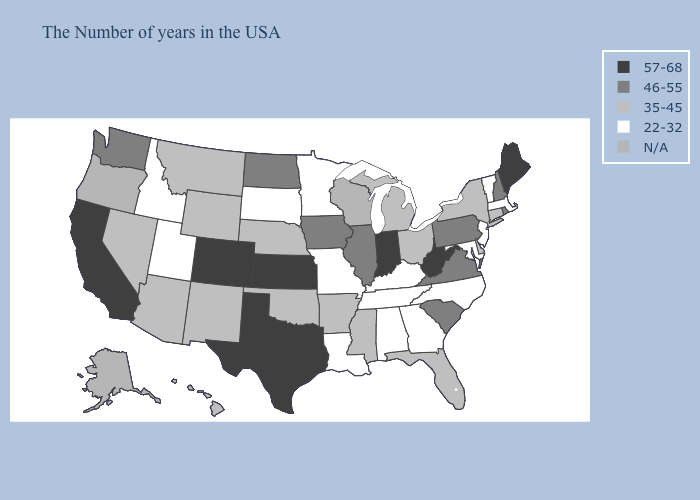How many symbols are there in the legend?
Concise answer only. 5. Does Oklahoma have the lowest value in the USA?
Keep it brief. No. Does the first symbol in the legend represent the smallest category?
Be succinct. No. Does Indiana have the highest value in the MidWest?
Short answer required. Yes. Is the legend a continuous bar?
Be succinct. No. Name the states that have a value in the range 57-68?
Give a very brief answer. Maine, West Virginia, Indiana, Kansas, Texas, Colorado, California. Which states have the highest value in the USA?
Write a very short answer. Maine, West Virginia, Indiana, Kansas, Texas, Colorado, California. Is the legend a continuous bar?
Short answer required. No. What is the value of Kentucky?
Keep it brief. 22-32. Among the states that border Iowa , which have the highest value?
Answer briefly. Illinois. Which states hav the highest value in the South?
Give a very brief answer. West Virginia, Texas. What is the lowest value in the USA?
Quick response, please. 22-32. What is the lowest value in states that border Florida?
Keep it brief. 22-32. Does the first symbol in the legend represent the smallest category?
Be succinct. No. 